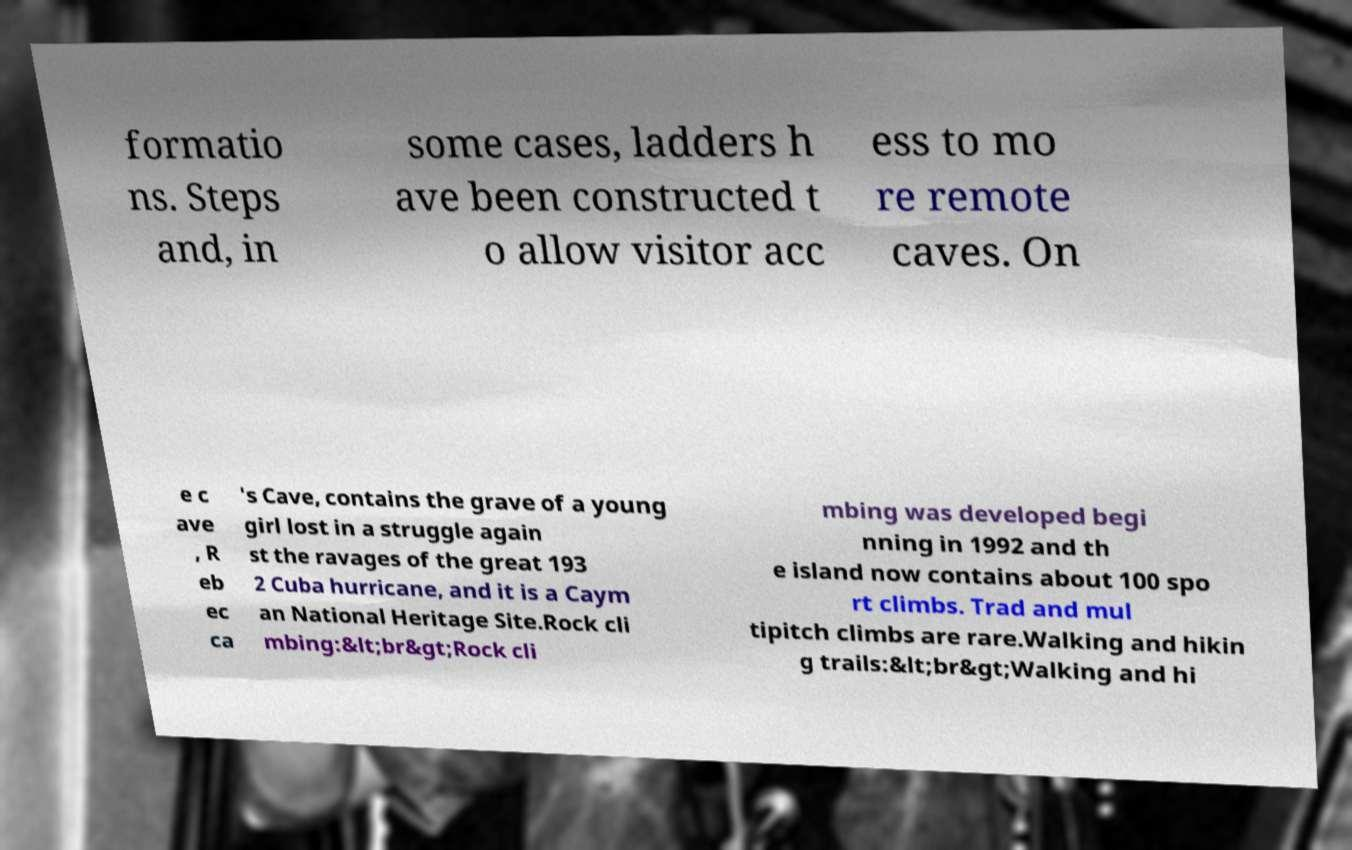There's text embedded in this image that I need extracted. Can you transcribe it verbatim? formatio ns. Steps and, in some cases, ladders h ave been constructed t o allow visitor acc ess to mo re remote caves. On e c ave , R eb ec ca 's Cave, contains the grave of a young girl lost in a struggle again st the ravages of the great 193 2 Cuba hurricane, and it is a Caym an National Heritage Site.Rock cli mbing:&lt;br&gt;Rock cli mbing was developed begi nning in 1992 and th e island now contains about 100 spo rt climbs. Trad and mul tipitch climbs are rare.Walking and hikin g trails:&lt;br&gt;Walking and hi 